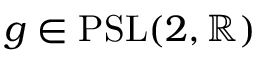<formula> <loc_0><loc_0><loc_500><loc_500>g \in { P S L } ( 2 , \mathbb { R } )</formula> 